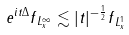Convert formula to latex. <formula><loc_0><loc_0><loc_500><loc_500>\| e ^ { i t \Delta } f \| _ { L ^ { \infty } _ { x } } \lesssim | t | ^ { - \frac { 1 } { 2 } } \| f \| _ { L ^ { 1 } _ { x } }</formula> 